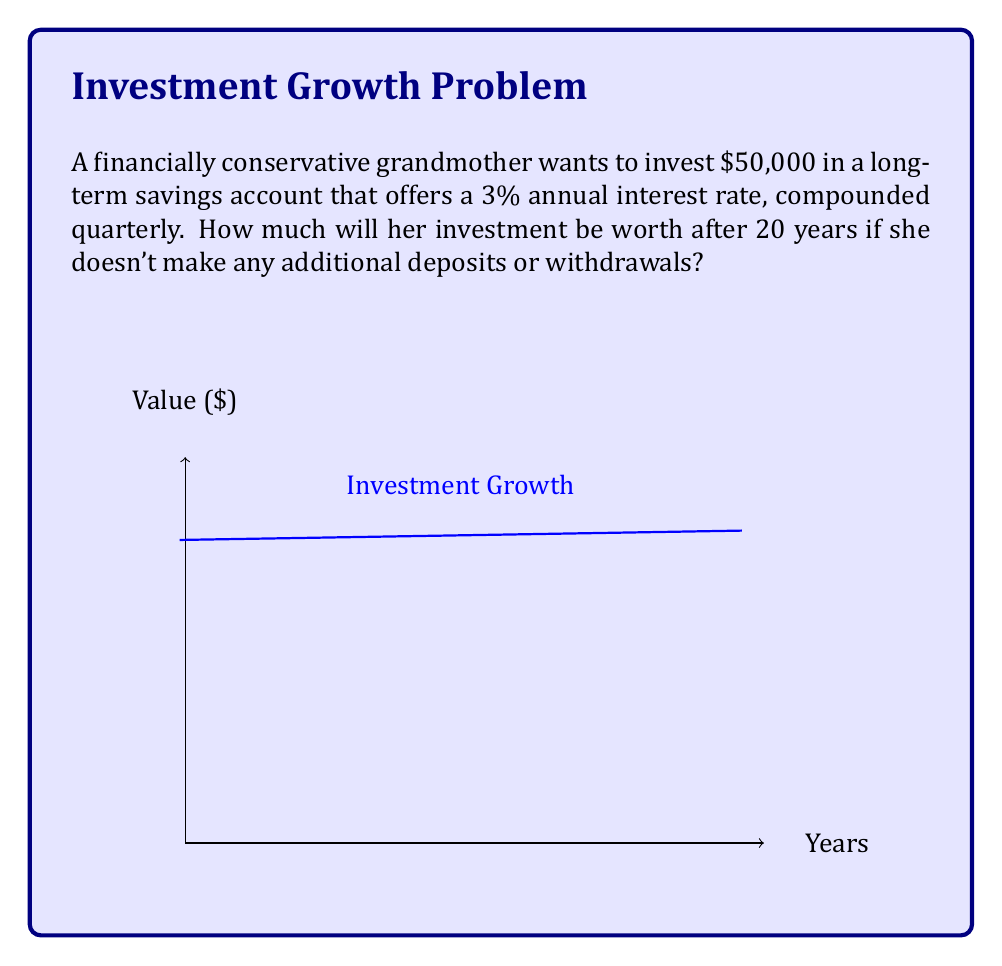Give your solution to this math problem. To solve this problem, we'll use the compound interest formula:

$$A = P(1 + \frac{r}{n})^{nt}$$

Where:
$A$ = final amount
$P$ = principal (initial investment)
$r$ = annual interest rate (as a decimal)
$n$ = number of times interest is compounded per year
$t$ = number of years

Given:
$P = \$50,000$
$r = 0.03$ (3% as a decimal)
$n = 4$ (compounded quarterly)
$t = 20$ years

Let's substitute these values into the formula:

$$A = 50000(1 + \frac{0.03}{4})^{4 \times 20}$$

$$A = 50000(1 + 0.0075)^{80}$$

$$A = 50000(1.0075)^{80}$$

Using a calculator to evaluate this expression:

$$A = 50000 \times 1.819397...$$

$$A = 90969.85...$$

Rounding to the nearest cent:

$$A = \$90,969.85$$
Answer: $90,969.85 